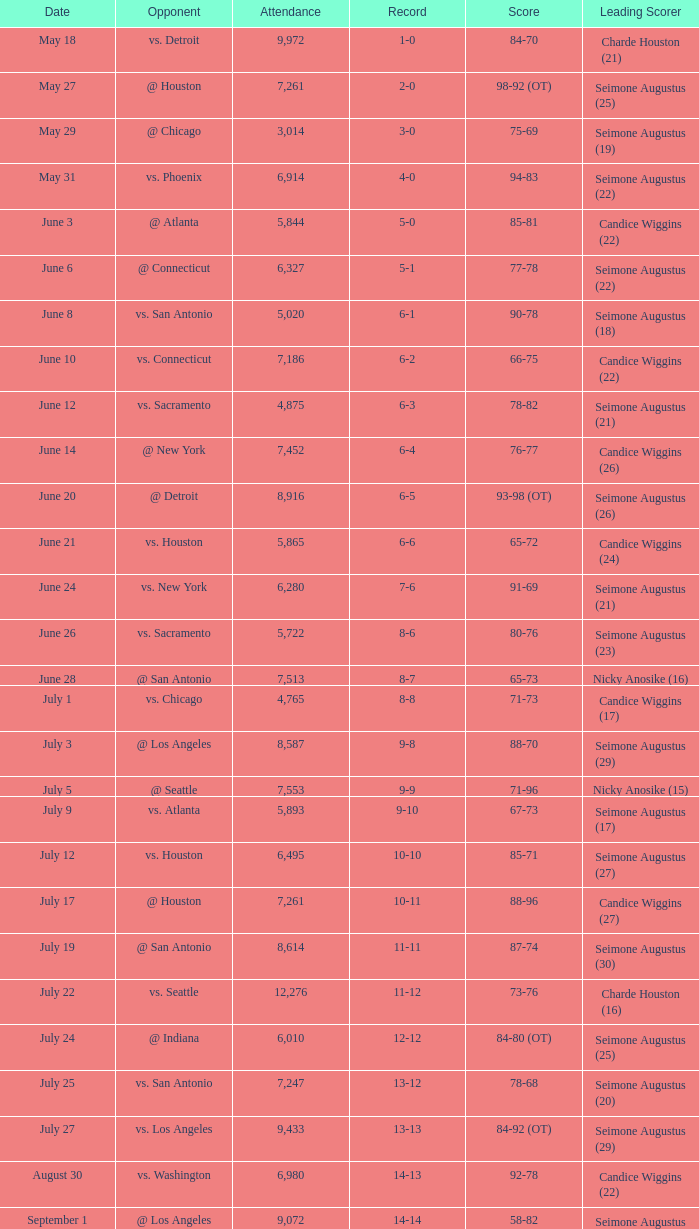Which Leading Scorer has an Opponent of @ seattle, and a Record of 14-16? Seimone Augustus (26). 